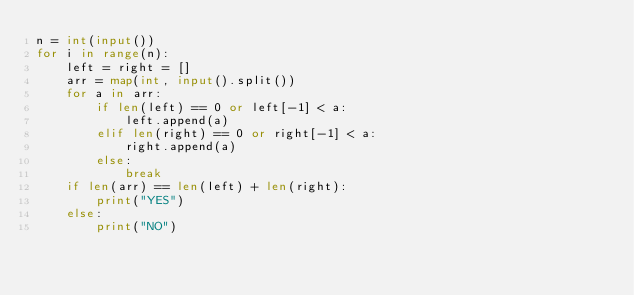Convert code to text. <code><loc_0><loc_0><loc_500><loc_500><_Python_>n = int(input())
for i in range(n):
    left = right = []
    arr = map(int, input().split())
    for a in arr:
        if len(left) == 0 or left[-1] < a:
            left.append(a)
        elif len(right) == 0 or right[-1] < a:
            right.append(a)
        else:
            break
    if len(arr) == len(left) + len(right):
        print("YES")
    else:
        print("NO")</code> 